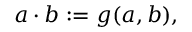Convert formula to latex. <formula><loc_0><loc_0><loc_500><loc_500>a \cdot b \colon = g ( a , b ) ,</formula> 